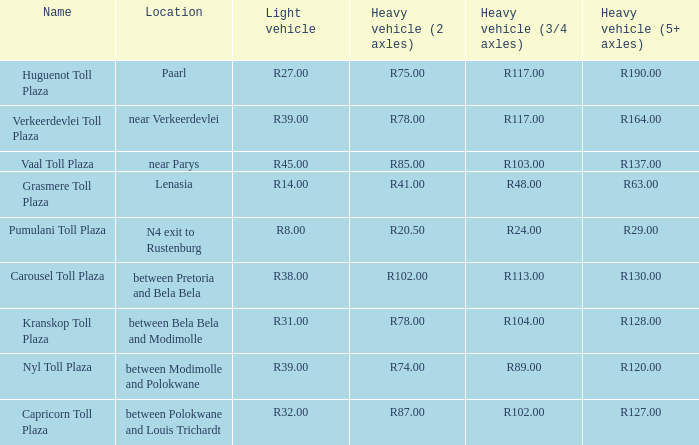50? Pumulani Toll Plaza. 